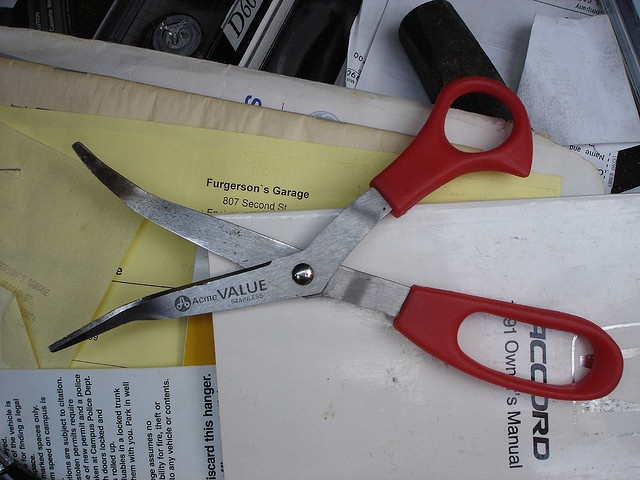Describe the objects in this image and their specific colors. I can see book in black, darkgray, maroon, and lightgray tones and scissors in black, maroon, darkgray, and gray tones in this image. 